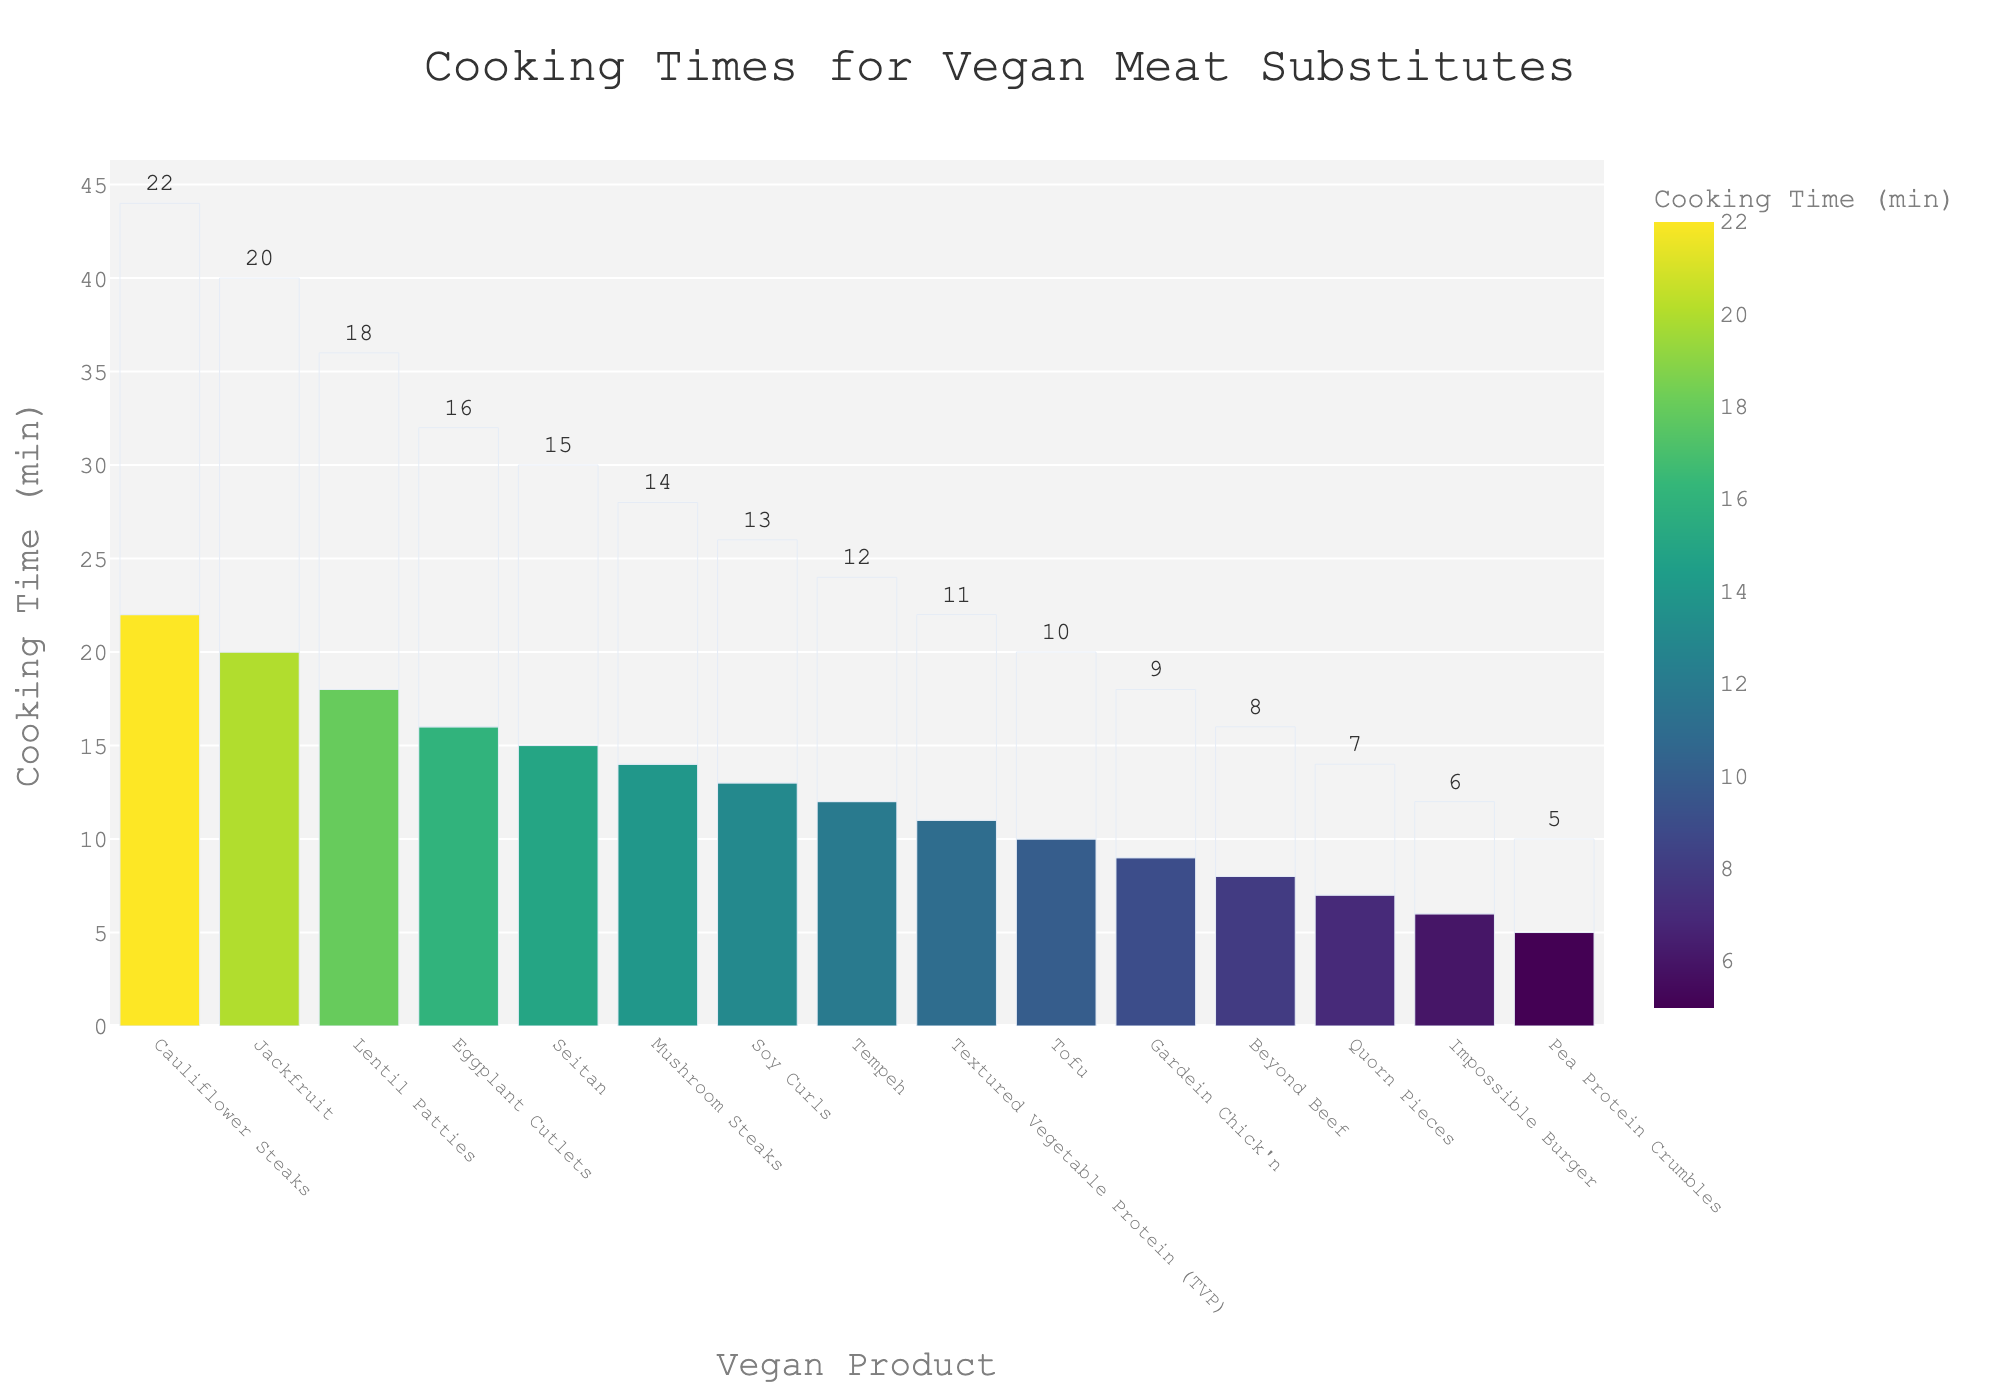What is the cooking time difference between Beyond Beef and Jackfruit? Beyond Beef takes 8 minutes to cook and Jackfruit takes 20 minutes to cook. The difference is calculated as 20 - 8 = 12 minutes.
Answer: 12 minutes Which product takes the longest time to cook? Cauliflower Steaks take the longest time to cook as they are shown with the tallest bar in the chart with a cooking time of 22 minutes.
Answer: Cauliflower Steaks Which two products have the closest cooking times? Beyond Beef and Gardein Chick'n have quite similar cooking times, with Beyond Beef at 8 minutes and Gardein Chick'n at 9 minutes, showing a difference of only 1 minute.
Answer: Beyond Beef and Gardein Chick'n What is the median cooking time for all the products listed? First, we list all the cooking times in ascending order: 5, 6, 7, 8, 9, 10, 11, 12, 13, 14, 15, 16, 18, 20, 22. There are 15 values, so the median is the 8th value, which is 12 minutes.
Answer: 12 minutes How many products have a cooking time greater than 15 minutes? From the chart, we can see that there are 4 products with cooking times greater than 15 minutes: Jackfruit, Lentil Patties, Eggplant Cutlets, and Cauliflower Steaks.
Answer: 4 products Which product has a cooking time exactly in the middle between the ones for Tofu and Seitan? Tofu has a cooking time of 10 minutes and Seitan has 15 minutes. A middle value between 10 and 15 is 12. Tempeh, with a cooking time of 12 minutes, fits this description.
Answer: Tempeh Is the cooking time for Textured Vegetable Protein (TVP) greater than that of Mushroom Steaks? The cooking time for TVP is 11 minutes, and for Mushroom Steaks, it is 14 minutes. Since 11 is not greater than 14, TVP does not have a greater cooking time.
Answer: No Compare the cooking times for Pea Protein Crumbles and Quorn Pieces. Which is shorter? Pea Protein Crumbles have a cooking time of 5 minutes, while Quorn Pieces have a cooking time of 7 minutes. Therefore, Pea Protein Crumbles have a shorter cooking time.
Answer: Pea Protein Crumbles What is the average cooking time for the products with the shortest and the longest cooking times? The products with the shortest and longest cooking times are Pea Protein Crumbles (5 minutes) and Cauliflower Steaks (22 minutes). The average is (5 + 22) / 2 = 13.5 minutes.
Answer: 13.5 minutes How does the cooking time for Soy Curls compare to the average cooking time of all products? The average cooking time for all products can be calculated by summing all the times and dividing by 15. Sum is (8+6+15+20+12+10+7+9+18+14+16+22+5+11+13) = 186. Average is 186 / 15 = 12.4 minutes. Soy Curls have a cooking time of 13 minutes, which is slightly higher than the average of 12.4 minutes.
Answer: Slightly higher 